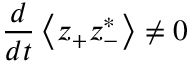<formula> <loc_0><loc_0><loc_500><loc_500>\frac { d } { d t } \left \langle z _ { + } z _ { - } ^ { * } \right \rangle \neq 0</formula> 